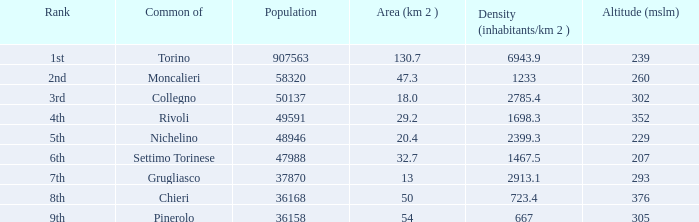What is the crowdedness level in the common of chieri? 723.4. 